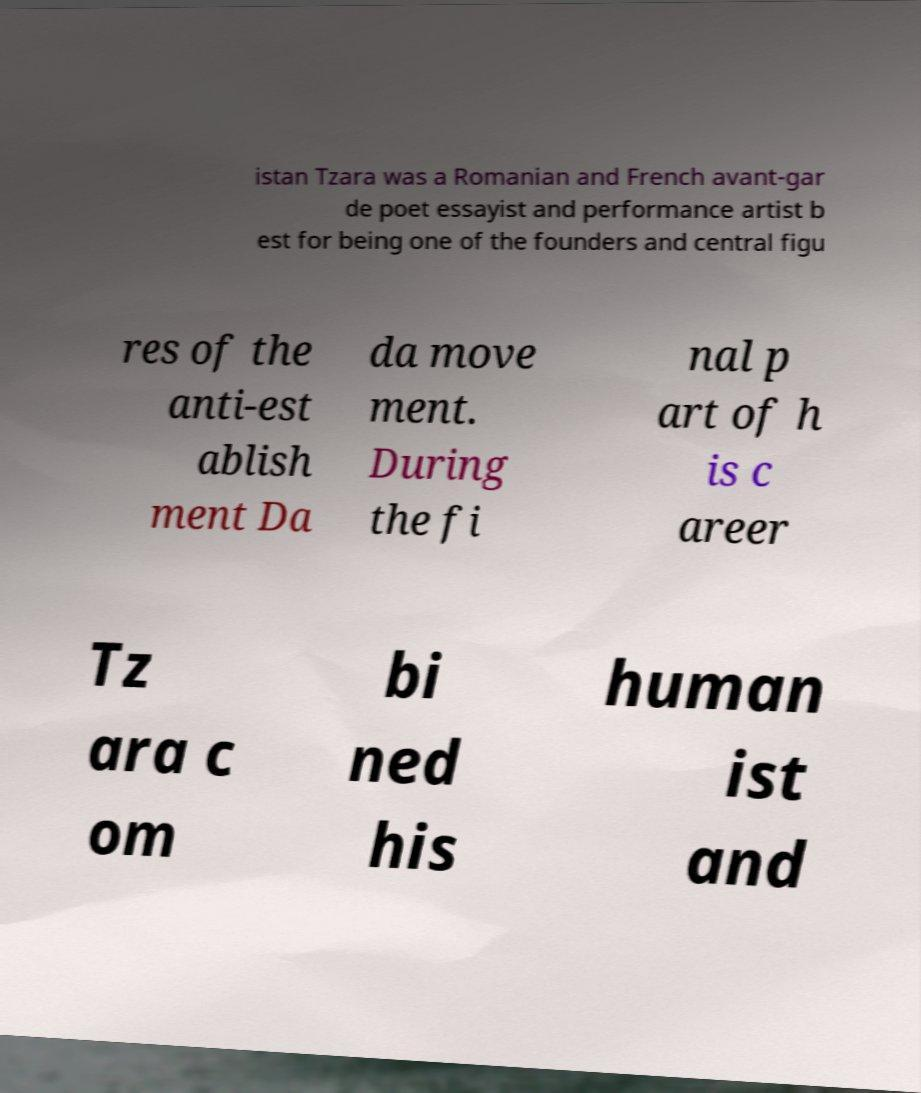For documentation purposes, I need the text within this image transcribed. Could you provide that? istan Tzara was a Romanian and French avant-gar de poet essayist and performance artist b est for being one of the founders and central figu res of the anti-est ablish ment Da da move ment. During the fi nal p art of h is c areer Tz ara c om bi ned his human ist and 